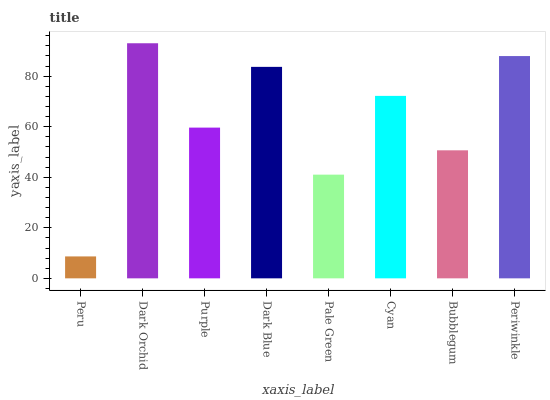Is Peru the minimum?
Answer yes or no. Yes. Is Dark Orchid the maximum?
Answer yes or no. Yes. Is Purple the minimum?
Answer yes or no. No. Is Purple the maximum?
Answer yes or no. No. Is Dark Orchid greater than Purple?
Answer yes or no. Yes. Is Purple less than Dark Orchid?
Answer yes or no. Yes. Is Purple greater than Dark Orchid?
Answer yes or no. No. Is Dark Orchid less than Purple?
Answer yes or no. No. Is Cyan the high median?
Answer yes or no. Yes. Is Purple the low median?
Answer yes or no. Yes. Is Bubblegum the high median?
Answer yes or no. No. Is Dark Blue the low median?
Answer yes or no. No. 